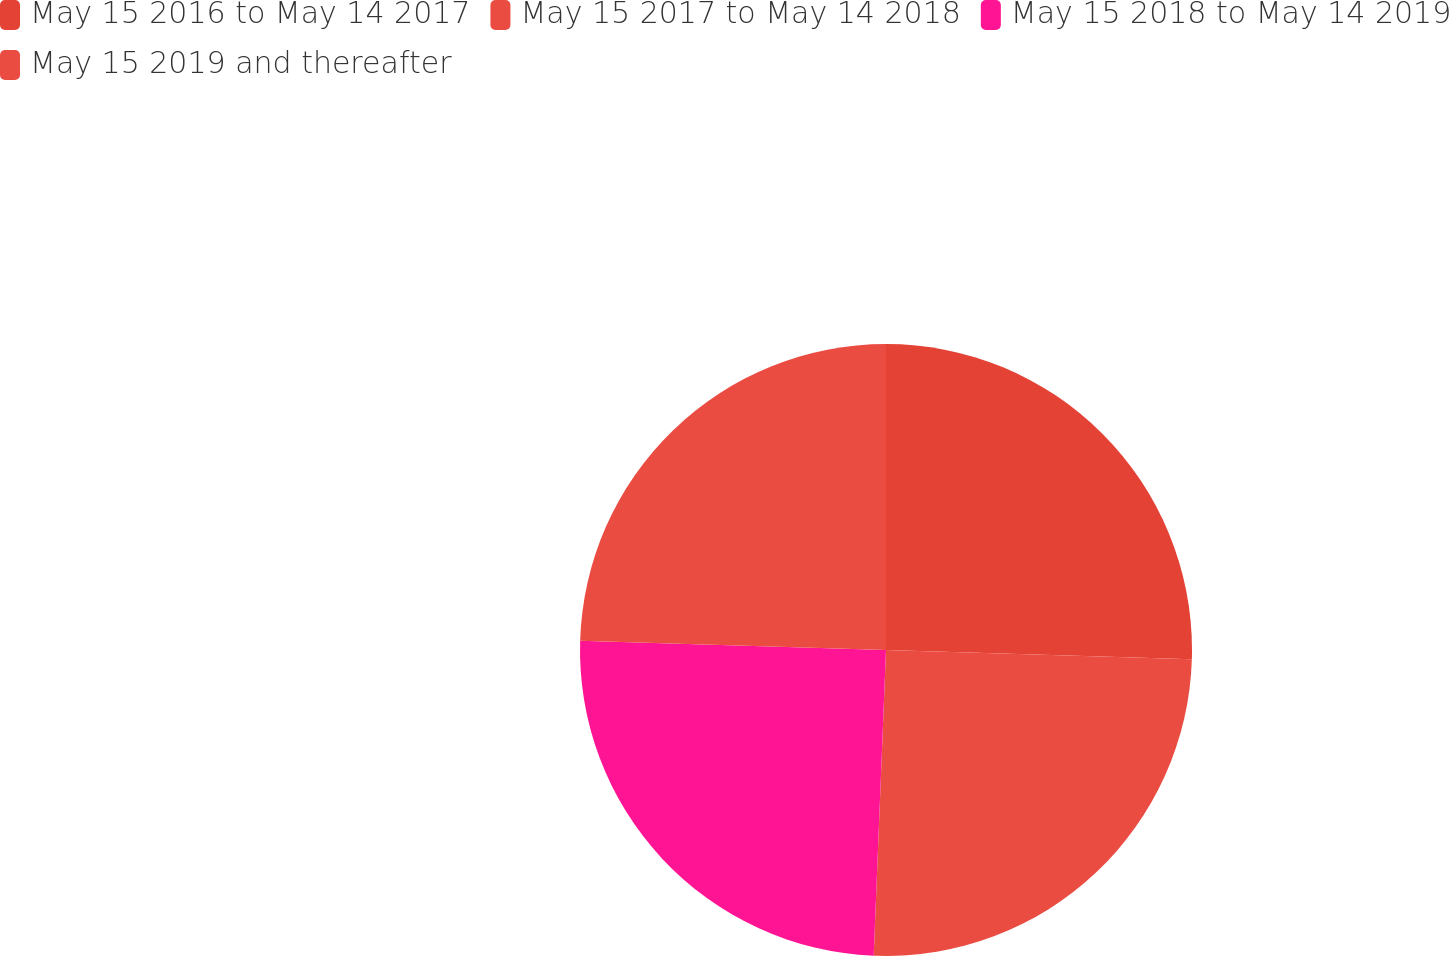Convert chart. <chart><loc_0><loc_0><loc_500><loc_500><pie_chart><fcel>May 15 2016 to May 14 2017<fcel>May 15 2017 to May 14 2018<fcel>May 15 2018 to May 14 2019<fcel>May 15 2019 and thereafter<nl><fcel>25.48%<fcel>25.16%<fcel>24.84%<fcel>24.52%<nl></chart> 